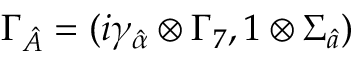<formula> <loc_0><loc_0><loc_500><loc_500>\Gamma _ { \hat { A } } = ( i \gamma _ { \hat { \alpha } } \otimes \Gamma _ { 7 } , 1 \otimes \Sigma _ { \hat { a } } )</formula> 